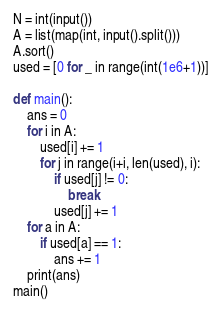Convert code to text. <code><loc_0><loc_0><loc_500><loc_500><_Python_>N = int(input())
A = list(map(int, input().split()))
A.sort()
used = [0 for _ in range(int(1e6+1))]

def main():
    ans = 0
    for i in A:
        used[i] += 1
        for j in range(i+i, len(used), i):
            if used[j] != 0:
                break
            used[j] += 1
    for a in A:
        if used[a] == 1:
            ans += 1
    print(ans)
main()
</code> 